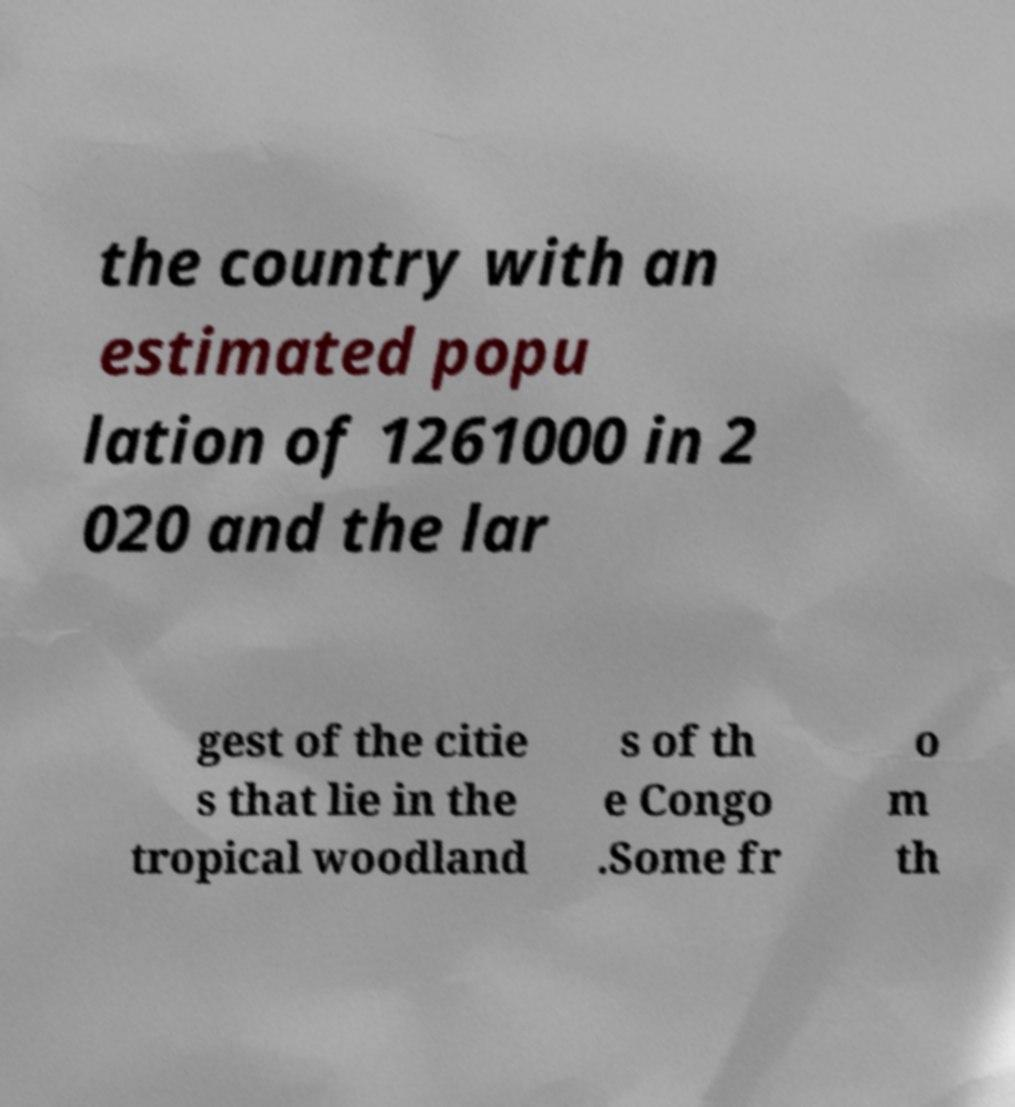For documentation purposes, I need the text within this image transcribed. Could you provide that? the country with an estimated popu lation of 1261000 in 2 020 and the lar gest of the citie s that lie in the tropical woodland s of th e Congo .Some fr o m th 